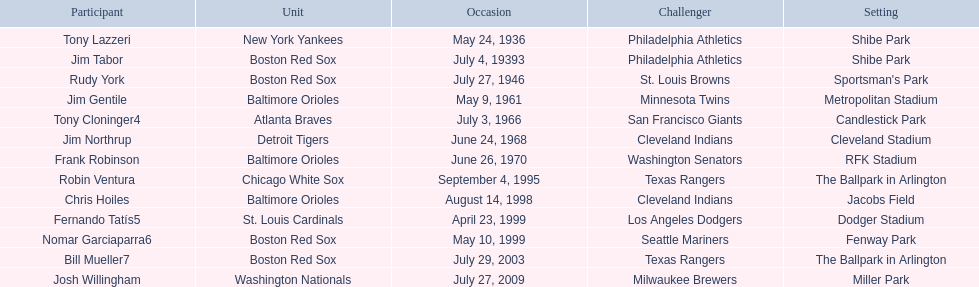What venue did detroit play cleveland in? Cleveland Stadium. Who was the player? Jim Northrup. What date did they play? June 24, 1968. 